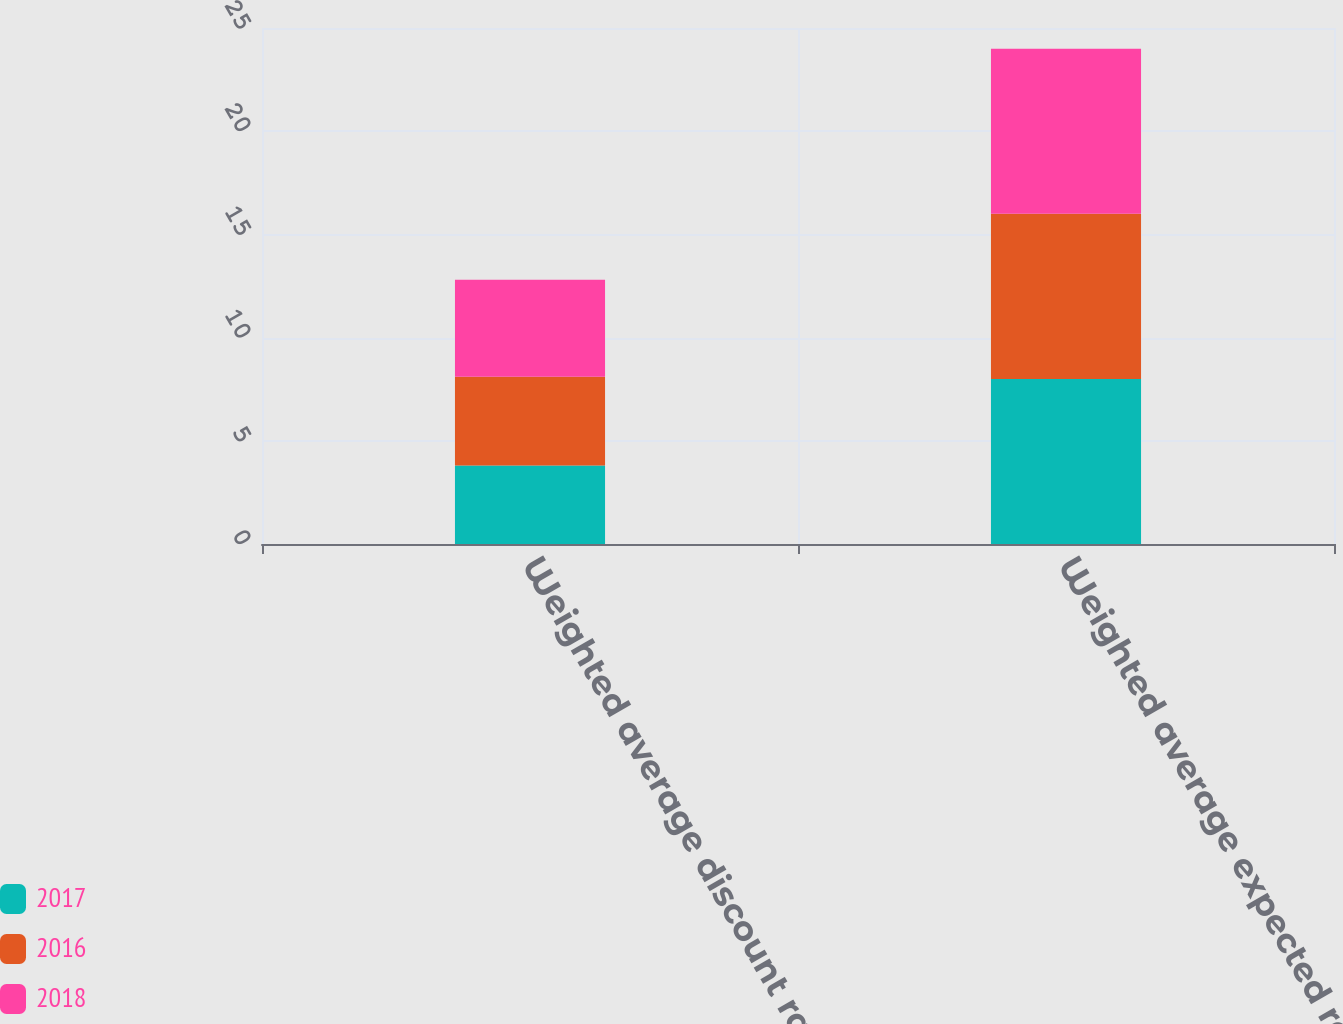Convert chart. <chart><loc_0><loc_0><loc_500><loc_500><stacked_bar_chart><ecel><fcel>Weighted average discount rate<fcel>Weighted average expected rate<nl><fcel>2017<fcel>3.8<fcel>8<nl><fcel>2016<fcel>4.3<fcel>8<nl><fcel>2018<fcel>4.7<fcel>8<nl></chart> 